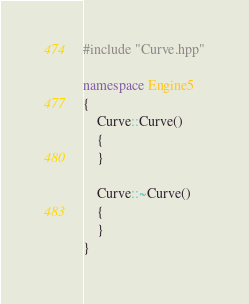Convert code to text. <code><loc_0><loc_0><loc_500><loc_500><_C++_>#include "Curve.hpp"

namespace Engine5
{
    Curve::Curve()
    {
    }

    Curve::~Curve()
    {
    }
}
</code> 